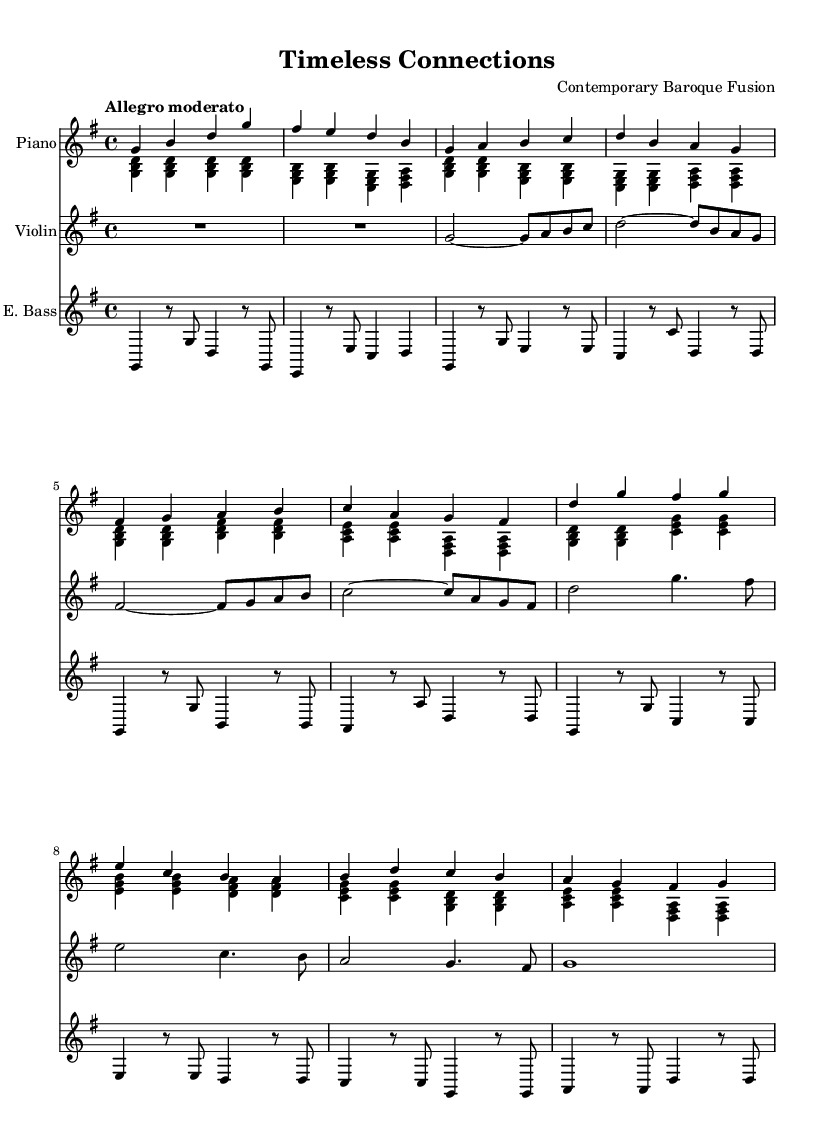What is the key signature of this music? The key signature is G major, which has one sharp (F#). This can be determined from the key signature indicated at the beginning of the music.
Answer: G major What is the time signature of this music? The time signature is 4/4, shown at the beginning of the score as well, indicating four beats in a measure.
Answer: 4/4 What is the tempo marking of this piece? The tempo marking is "Allegro moderato," which suggests a moderate fast pace. This is found at the beginning of the sheet music under the global settings.
Answer: Allegro moderato How many measures are in the verse section? The verse section consists of 8 measures. By counting the bars in the designated verse part of the score, we find that there are 8 distinct measures.
Answer: 8 What is the highest note played by the violin? The highest note played by the violin is D' (D in the octave above middle C). This is discerned from the violin part, where the note D' appears in the chorus section.
Answer: D' What type of harmony is primarily used in this piece? The piece typically uses triadic harmony, which involves chords built from three notes. This is visible in the left hand of the piano and various instruments where triads are formed.
Answer: Triadic harmony What aspect of Baroque music is reflected in the composition style? The composition reflects a polyphonic texture, common in Baroque music, where multiple independent melodies are interwoven, which can be noted in the arrangement where parts interact harmoniously.
Answer: Polyphonic texture 